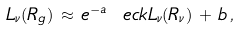Convert formula to latex. <formula><loc_0><loc_0><loc_500><loc_500>L _ { \nu } ( R _ { g } ) \, \approx \, { e } ^ { - a } \ e c k { L _ { \nu } ( R _ { \nu } ) \, + \, b } \, ,</formula> 